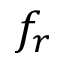<formula> <loc_0><loc_0><loc_500><loc_500>f _ { r }</formula> 